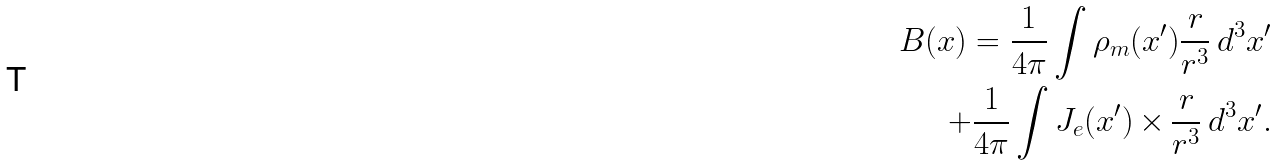Convert formula to latex. <formula><loc_0><loc_0><loc_500><loc_500>B ( x ) = \frac { 1 } { 4 \pi } \int \rho _ { m } ( x ^ { \prime } ) \frac { r } { r ^ { 3 } } \, d ^ { 3 } x ^ { \prime } \\ + \frac { 1 } { 4 \pi } \int J _ { e } ( x ^ { \prime } ) \, { \times } \, \frac { r } { r ^ { 3 } } \, d ^ { 3 } x ^ { \prime } .</formula> 